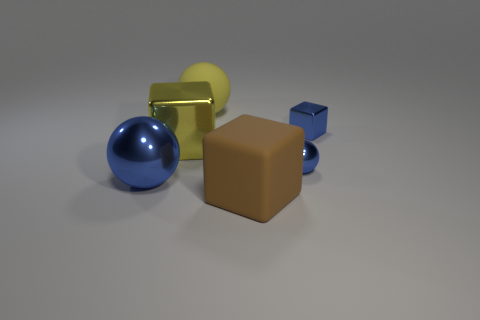There is a metal cube that is the same color as the rubber ball; what is its size?
Your answer should be very brief. Large. How many yellow matte spheres are the same size as the brown block?
Provide a succinct answer. 1. There is a blue thing that is behind the large yellow object that is in front of the tiny block; what number of small blue metallic things are on the left side of it?
Your answer should be very brief. 1. Is the number of large yellow cubes in front of the big shiny ball the same as the number of metal things right of the small blue shiny sphere?
Your answer should be very brief. No. How many other things have the same shape as the brown object?
Offer a very short reply. 2. Is there a green block made of the same material as the small blue cube?
Provide a short and direct response. No. There is a large shiny object that is the same color as the big rubber ball; what is its shape?
Offer a very short reply. Cube. What number of cyan metal spheres are there?
Give a very brief answer. 0. How many spheres are either gray metallic objects or yellow matte things?
Provide a succinct answer. 1. There is another matte block that is the same size as the yellow cube; what is its color?
Your answer should be very brief. Brown. 